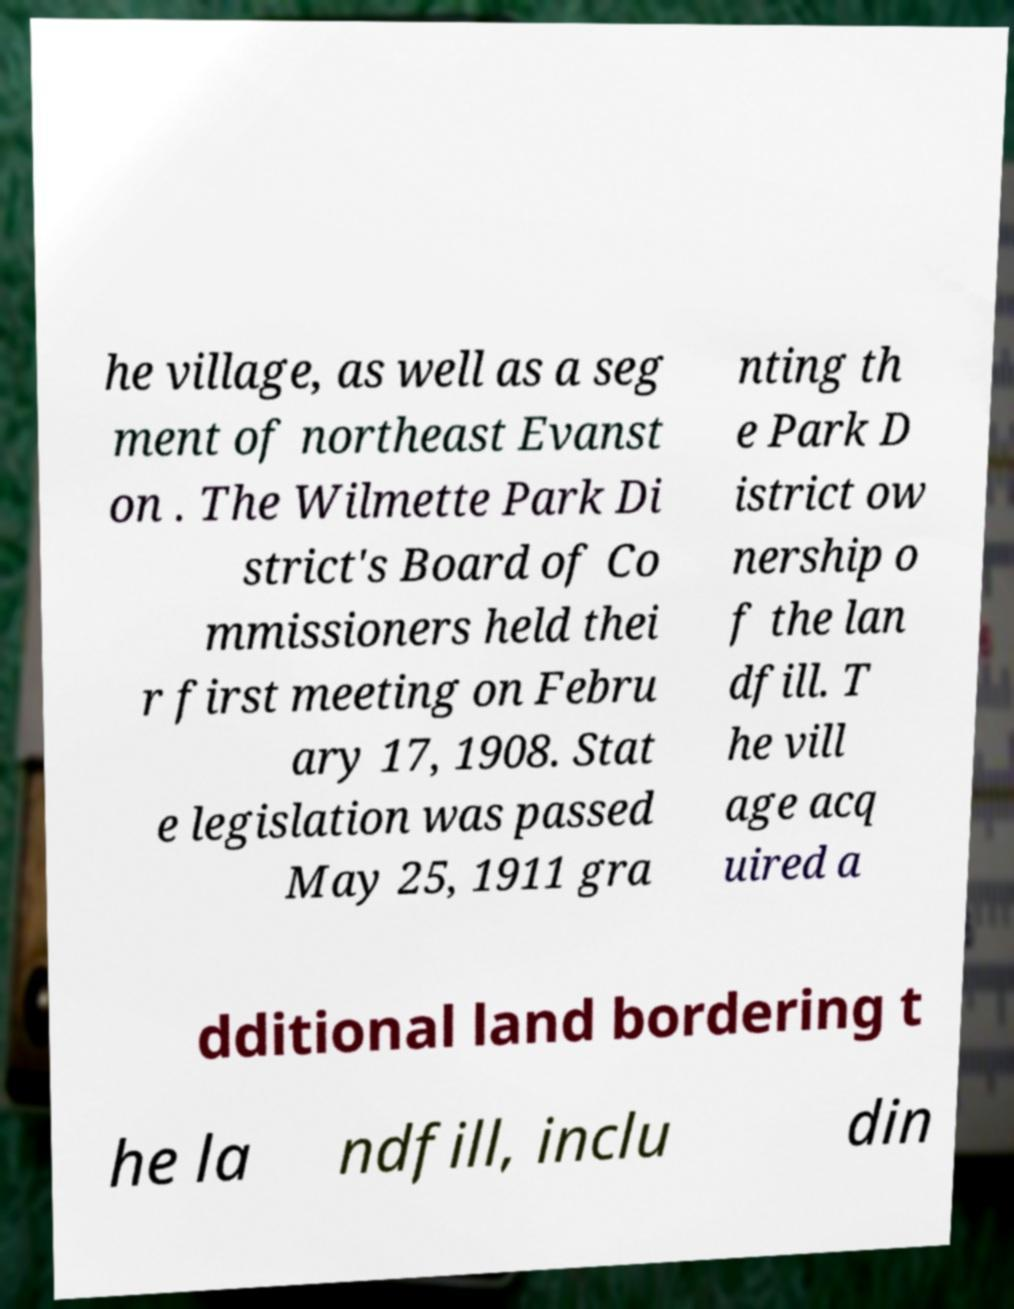Could you assist in decoding the text presented in this image and type it out clearly? he village, as well as a seg ment of northeast Evanst on . The Wilmette Park Di strict's Board of Co mmissioners held thei r first meeting on Febru ary 17, 1908. Stat e legislation was passed May 25, 1911 gra nting th e Park D istrict ow nership o f the lan dfill. T he vill age acq uired a dditional land bordering t he la ndfill, inclu din 